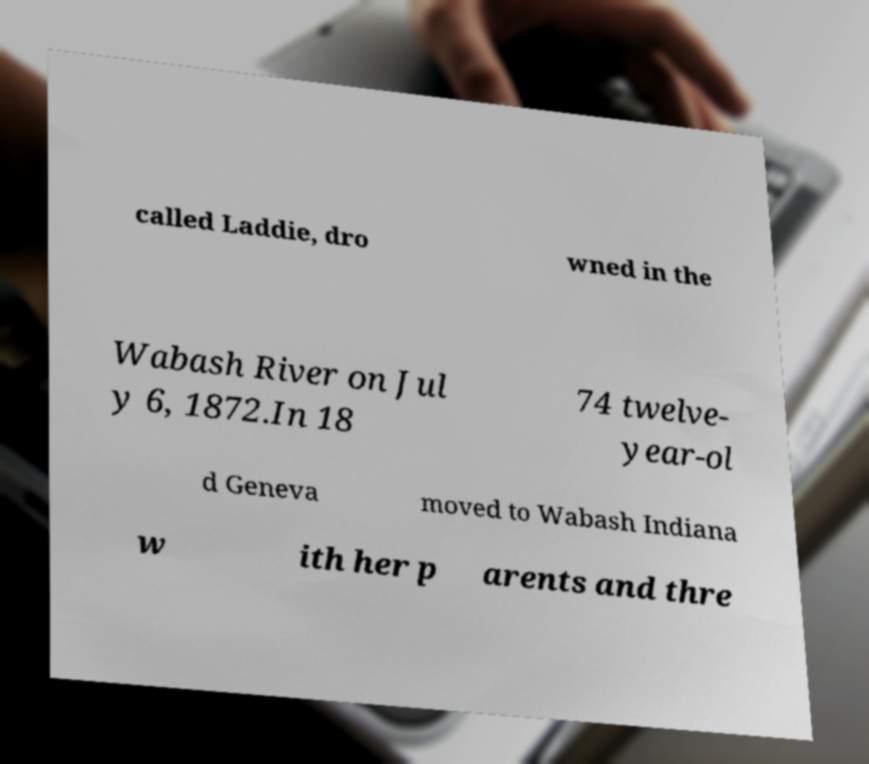Can you read and provide the text displayed in the image?This photo seems to have some interesting text. Can you extract and type it out for me? called Laddie, dro wned in the Wabash River on Jul y 6, 1872.In 18 74 twelve- year-ol d Geneva moved to Wabash Indiana w ith her p arents and thre 